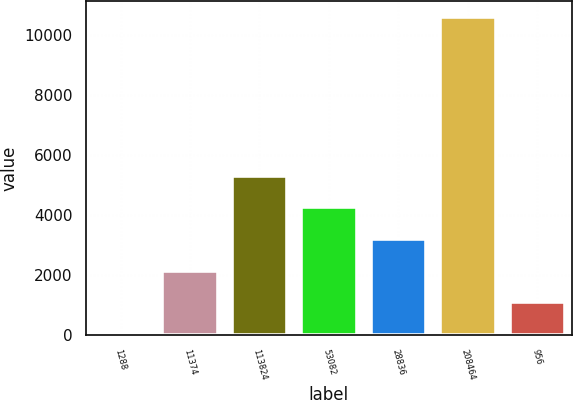<chart> <loc_0><loc_0><loc_500><loc_500><bar_chart><fcel>1288<fcel>11374<fcel>113824<fcel>53082<fcel>28836<fcel>208464<fcel>956<nl><fcel>18<fcel>2130.8<fcel>5300<fcel>4243.6<fcel>3187.2<fcel>10582<fcel>1074.4<nl></chart> 